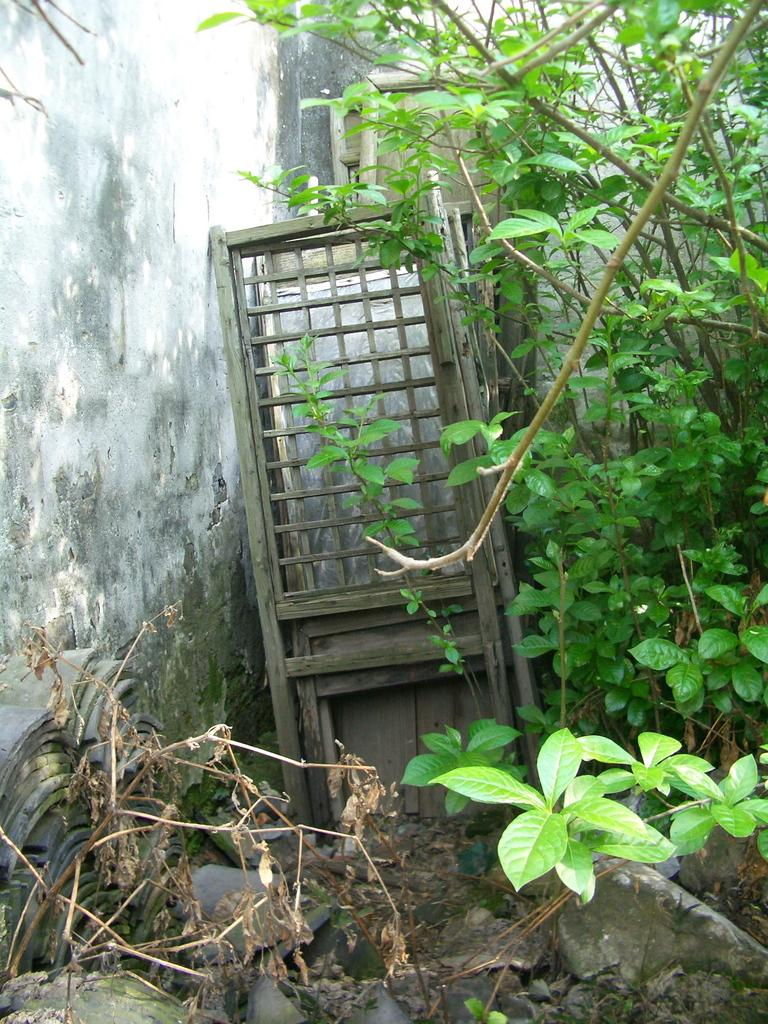What type of container is visible in the image? There is a wooden box in the image. What type of living organisms can be seen in the image? Plants and dried branches are present in the image. What type of natural elements can be seen in the image? Stones are visible in the image. What type of structure is present in the image? There is a wall in the image. What type of waste is being recycled in the image? There is no waste present in the image, and therefore no recycling can be observed. 